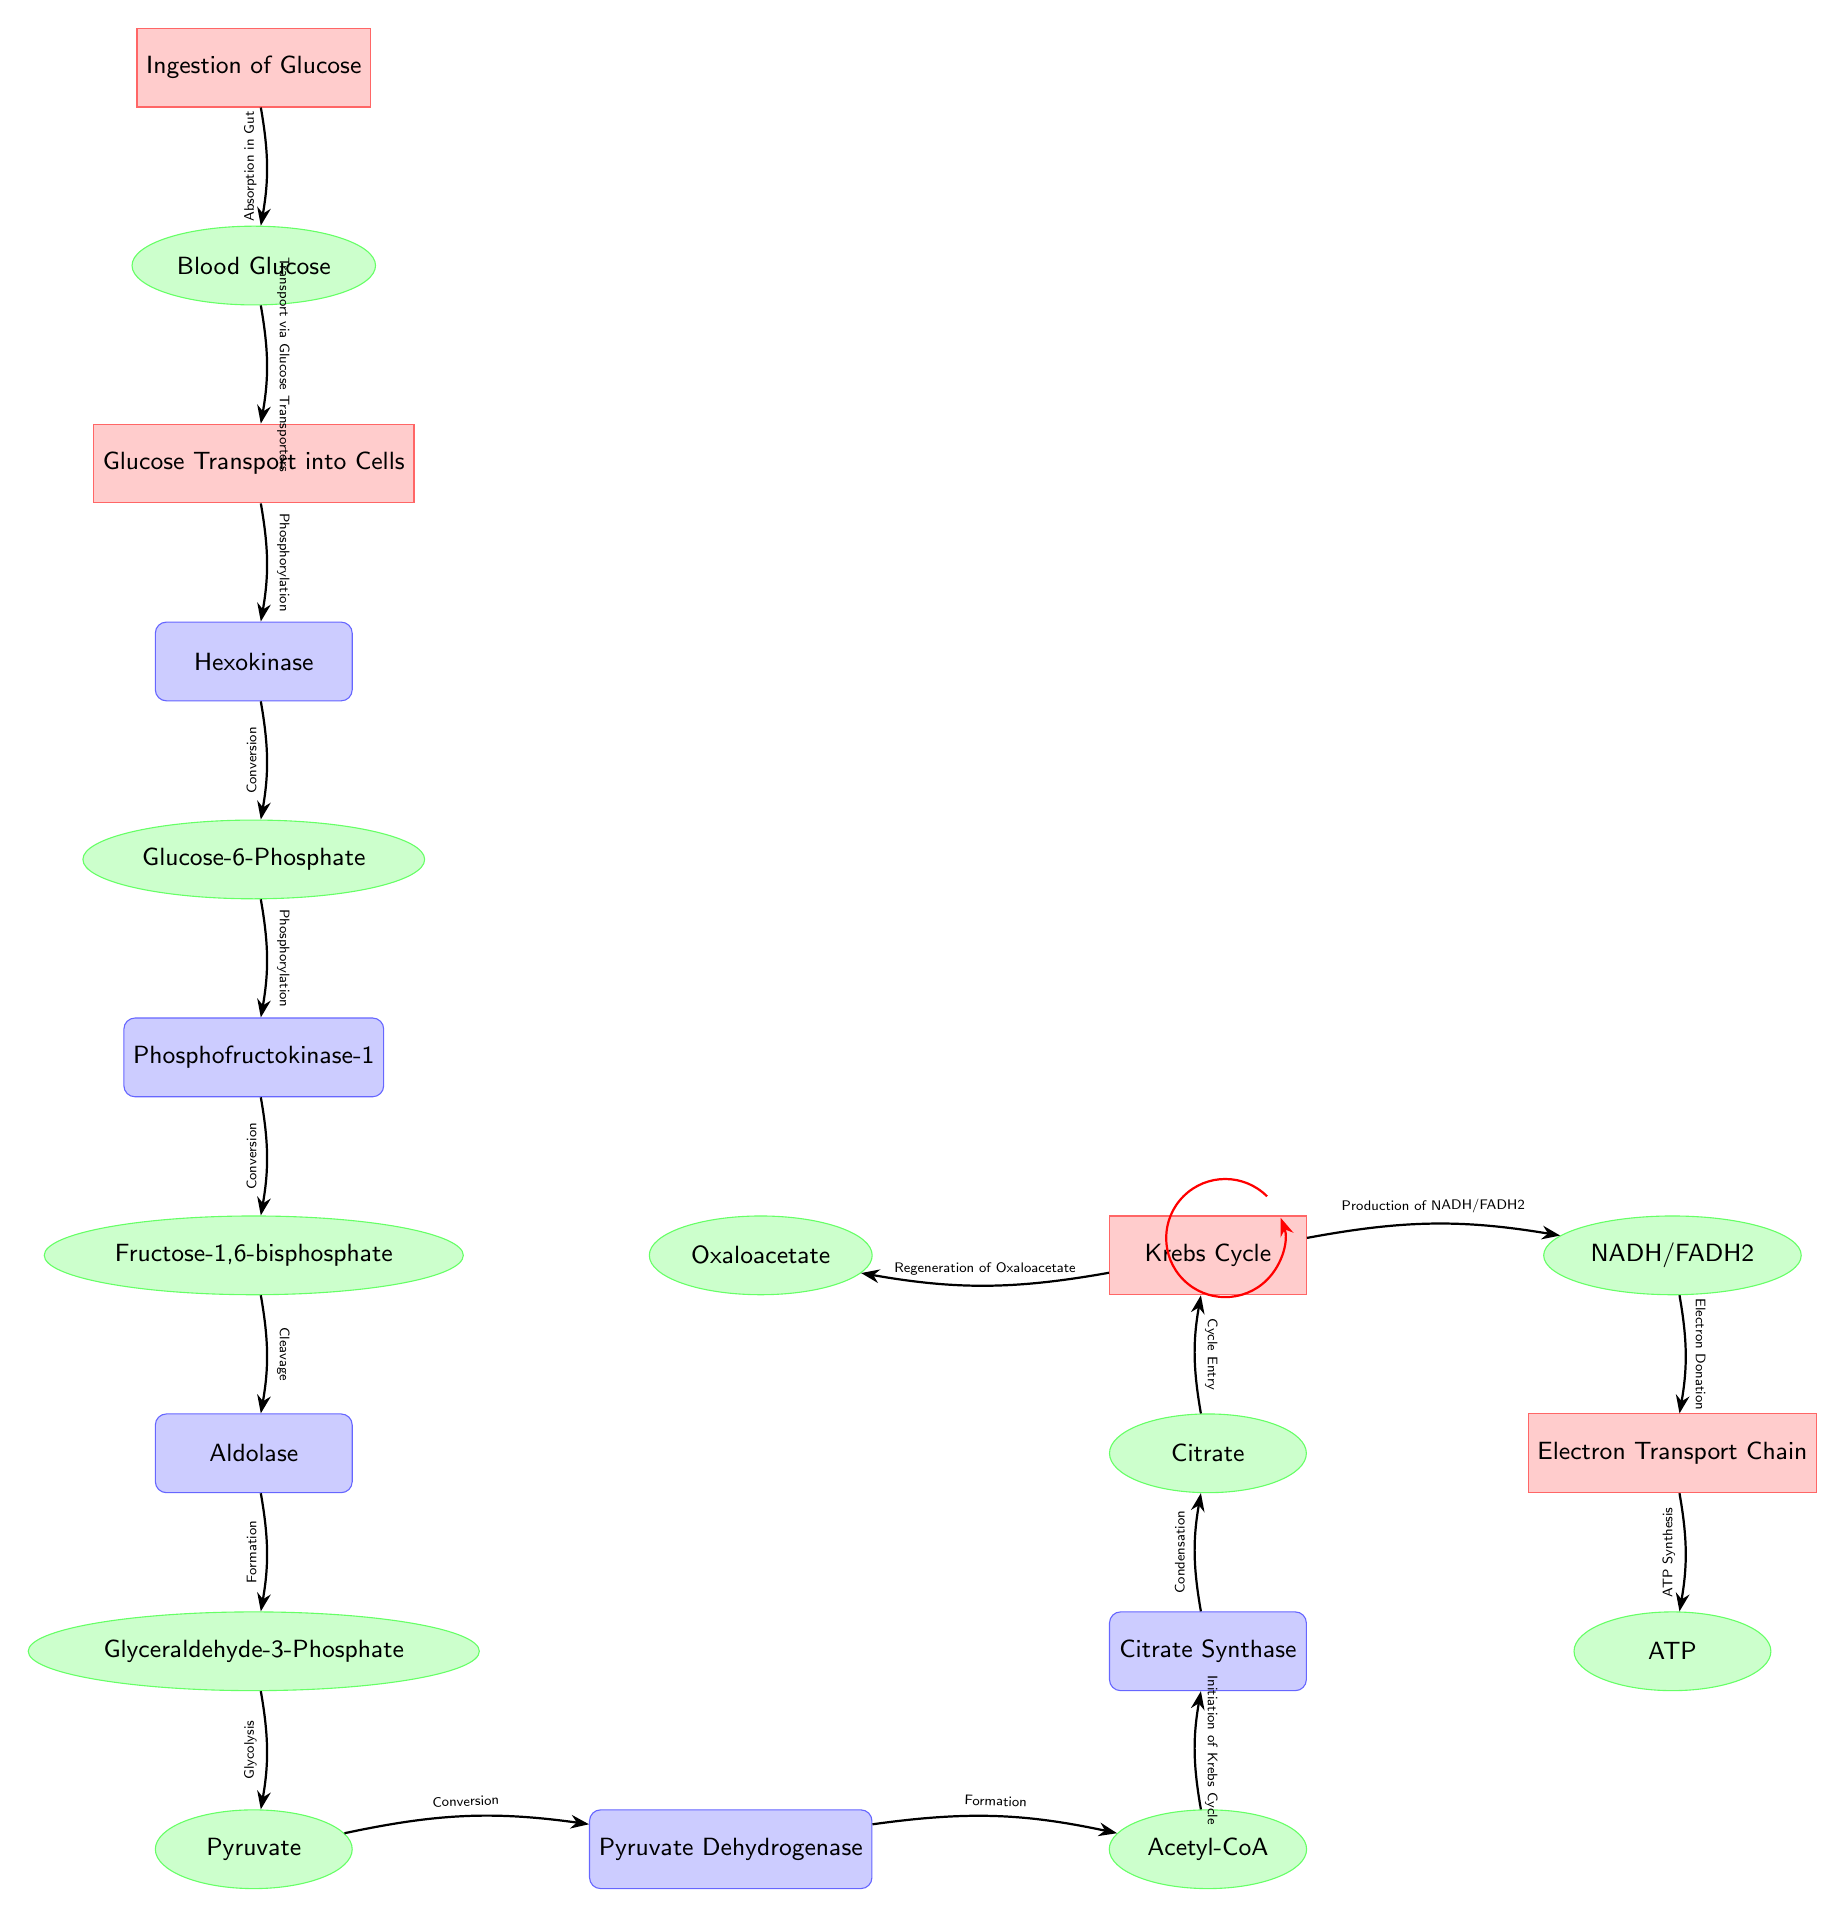What is the first process in the diagram? The first process depicted in the diagram is labeled "Ingestion of Glucose," which can be found at the top as the starting point of glucose metabolism.
Answer: Ingestion of Glucose How many enzymes are highlighted in the diagram? The diagram features seven highlighted enzymes: Hexokinase, Phosphofructokinase-1, Aldolase, Pyruvate Dehydrogenase, and Citrate Synthase, indicating the steps where enzymatic reactions occur.
Answer: Seven What molecule is produced after glycolysis? The molecule that is produced after glycolysis is Pyruvate, which is listed in the diagram as a result of the glycolytic pathway.
Answer: Pyruvate What is the role of Pyruvate Dehydrogenase? Pyruvate Dehydrogenase's role is to convert Pyruvate into Acetyl-CoA, facilitating the transition from glycolysis to the Krebs Cycle, as indicated by the arrow and description in the diagram.
Answer: Conversion What is regenerated at the end of the Krebs Cycle? The molecule that is regenerated at the end of the Krebs Cycle is Oxaloacetate, which can be observed in the process flow indicating the circular nature of the cycle.
Answer: Oxaloacetate Which process follows the Krebs Cycle in the energy production pathway? The process that follows the Krebs Cycle is the Electron Transport Chain, which takes place after the production of NADH and FADH2 in the Krebs Cycle to synthesize ATP.
Answer: Electron Transport Chain How is ATP produced in the diagram? ATP is produced through the process of ATP Synthesis in the Electron Transport Chain step, which captures the energy generated by the electrons as they are transferred along the chain.
Answer: ATP Synthesis What type of molecule is Fructose-1,6-bisphosphate? Fructose-1,6-bisphosphate is categorized as a molecule and is illustrated as an essential intermediate in the glycolytic pathway, shown clearly in the diagram.
Answer: Molecule 